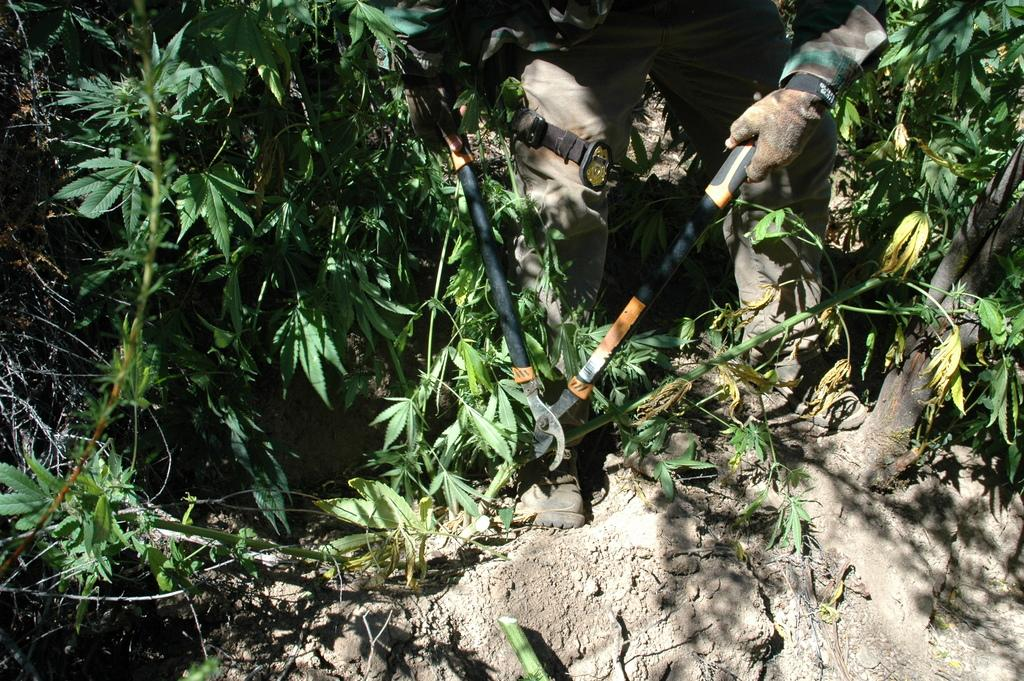What is the person in the image doing? The person in the image is cutting plants. Can you describe the setting of the image? There is sand visible in the image, which suggests a beach or sandy area. What type of lead is the person using to cut the plants in the image? There is no lead present in the image; the person is using a tool or their hands to cut the plants. 